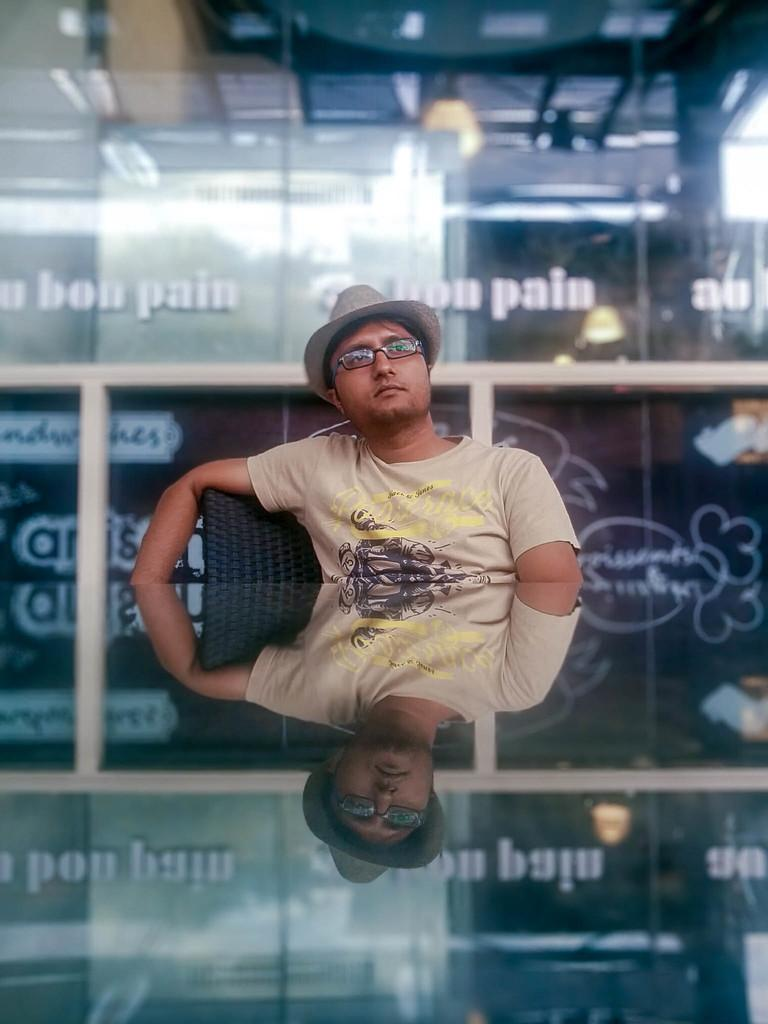What is the person in the image doing? The person is sitting on a chair in the image. Can you describe the person's appearance? The person is wearing spectacles and a hat. What can be seen in the background of the image? There is a mirror in the background of the image. What is written on the mirror? There is text written on the mirror. Is the person in the image offering a map to a boy? There is no boy or map present in the image. 